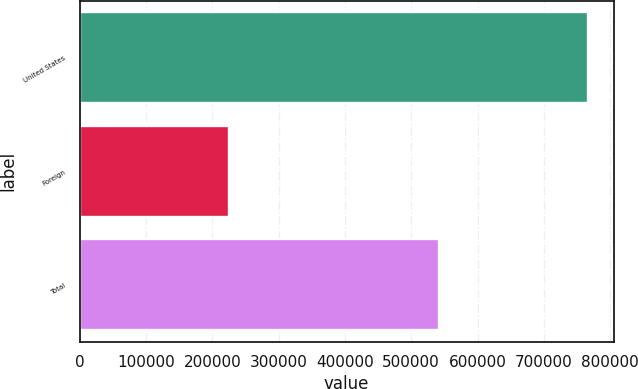<chart> <loc_0><loc_0><loc_500><loc_500><bar_chart><fcel>United States<fcel>Foreign<fcel>Total<nl><fcel>766772<fcel>225023<fcel>541749<nl></chart> 